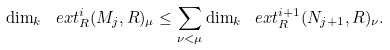<formula> <loc_0><loc_0><loc_500><loc_500>\dim _ { k } \ e x t ^ { i } _ { R } ( M _ { j } , R ) _ { \mu } \leq \sum _ { \nu < \mu } \dim _ { k } \ e x t ^ { i + 1 } _ { R } ( N _ { j + 1 } , R ) _ { \nu } .</formula> 